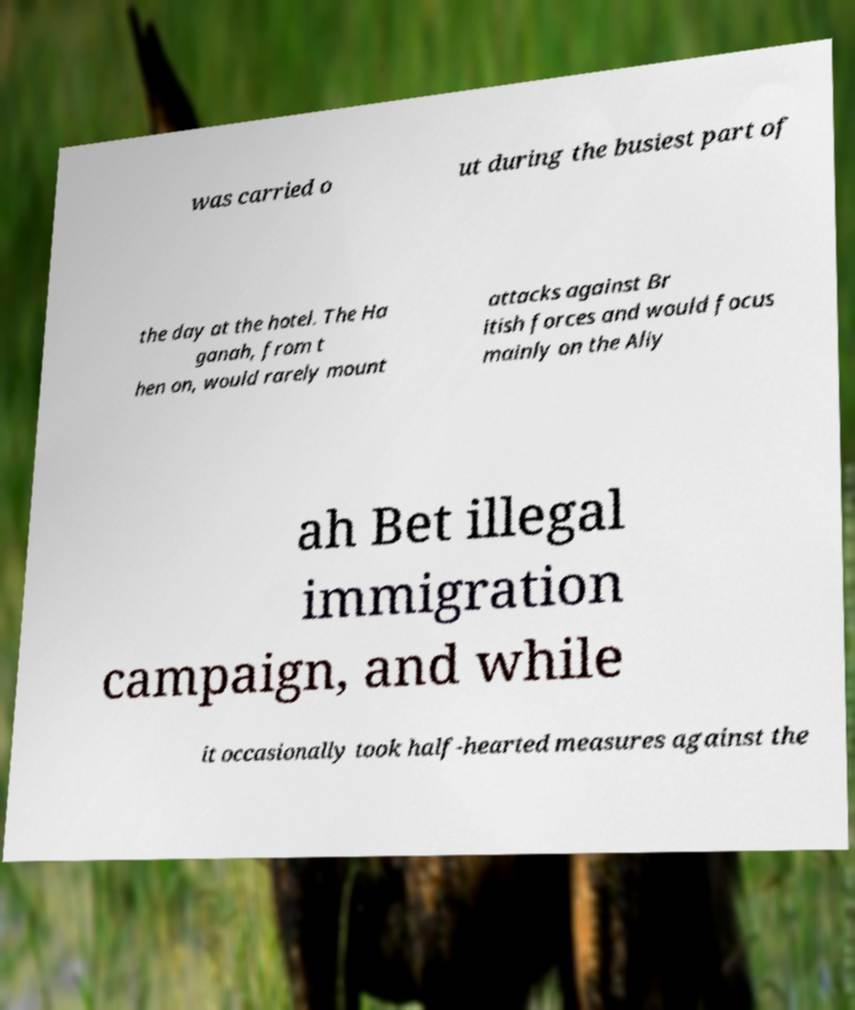I need the written content from this picture converted into text. Can you do that? was carried o ut during the busiest part of the day at the hotel. The Ha ganah, from t hen on, would rarely mount attacks against Br itish forces and would focus mainly on the Aliy ah Bet illegal immigration campaign, and while it occasionally took half-hearted measures against the 